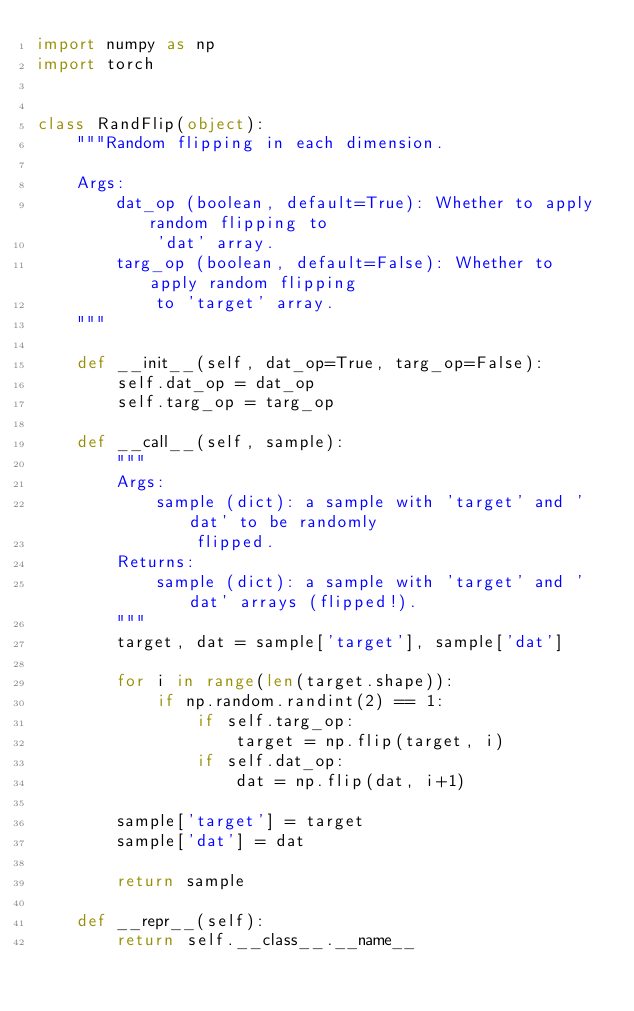Convert code to text. <code><loc_0><loc_0><loc_500><loc_500><_Python_>import numpy as np
import torch


class RandFlip(object):
    """Random flipping in each dimension.

    Args:
        dat_op (boolean, default=True): Whether to apply random flipping to
            'dat' array.
        targ_op (boolean, default=False): Whether to apply random flipping
            to 'target' array.
    """

    def __init__(self, dat_op=True, targ_op=False):
        self.dat_op = dat_op
        self.targ_op = targ_op

    def __call__(self, sample):
        """
        Args:
            sample (dict): a sample with 'target' and 'dat' to be randomly
                flipped.
        Returns:
            sample (dict): a sample with 'target' and 'dat' arrays (flipped!).
        """
        target, dat = sample['target'], sample['dat']

        for i in range(len(target.shape)):
            if np.random.randint(2) == 1:
                if self.targ_op:
                    target = np.flip(target, i)
                if self.dat_op:
                    dat = np.flip(dat, i+1)

        sample['target'] = target
        sample['dat'] = dat

        return sample

    def __repr__(self):
        return self.__class__.__name__
</code> 